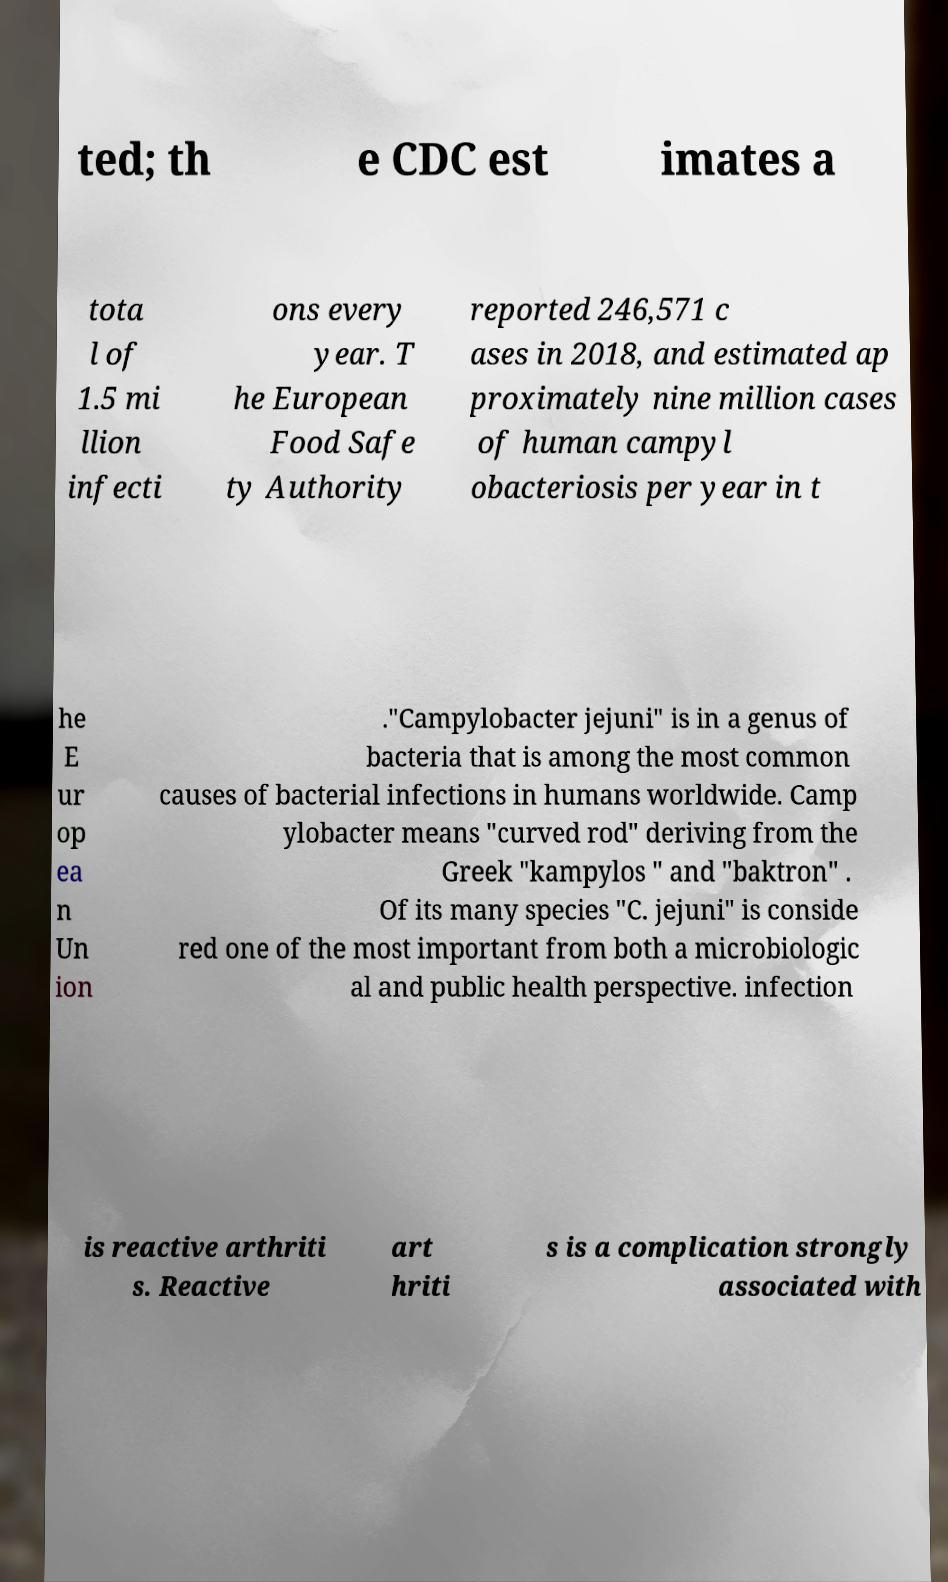There's text embedded in this image that I need extracted. Can you transcribe it verbatim? ted; th e CDC est imates a tota l of 1.5 mi llion infecti ons every year. T he European Food Safe ty Authority reported 246,571 c ases in 2018, and estimated ap proximately nine million cases of human campyl obacteriosis per year in t he E ur op ea n Un ion ."Campylobacter jejuni" is in a genus of bacteria that is among the most common causes of bacterial infections in humans worldwide. Camp ylobacter means "curved rod" deriving from the Greek "kampylos " and "baktron" . Of its many species "C. jejuni" is conside red one of the most important from both a microbiologic al and public health perspective. infection is reactive arthriti s. Reactive art hriti s is a complication strongly associated with 